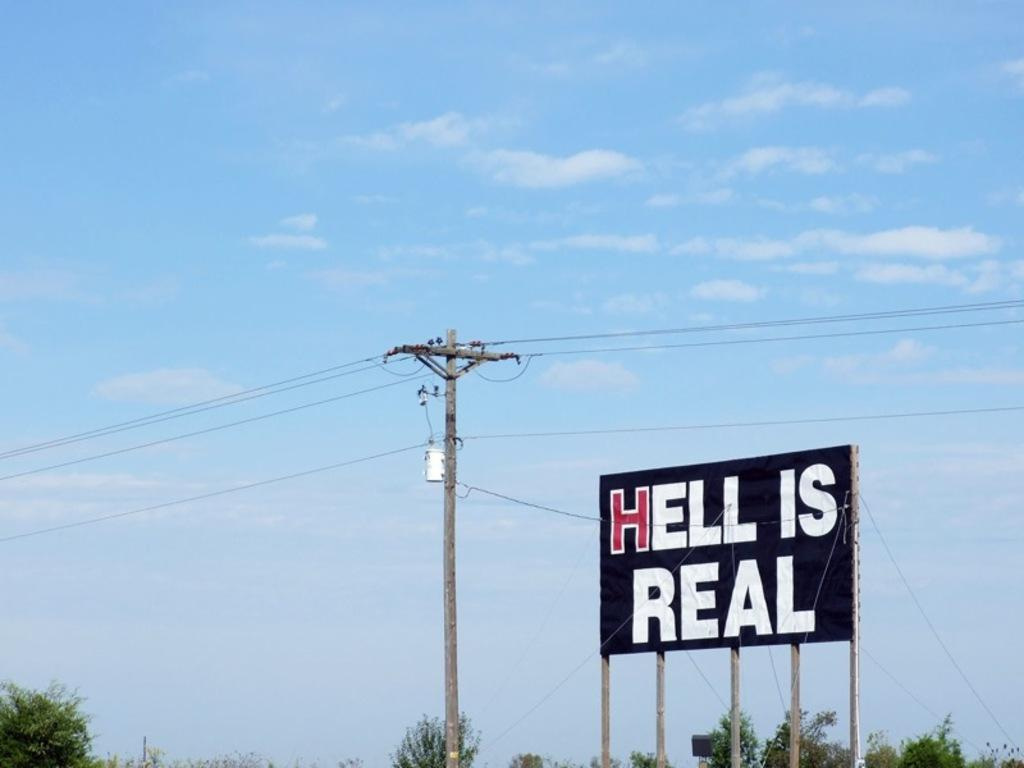Provide a one-sentence caption for the provided image. A large public sign that says HELL IS REAL. 